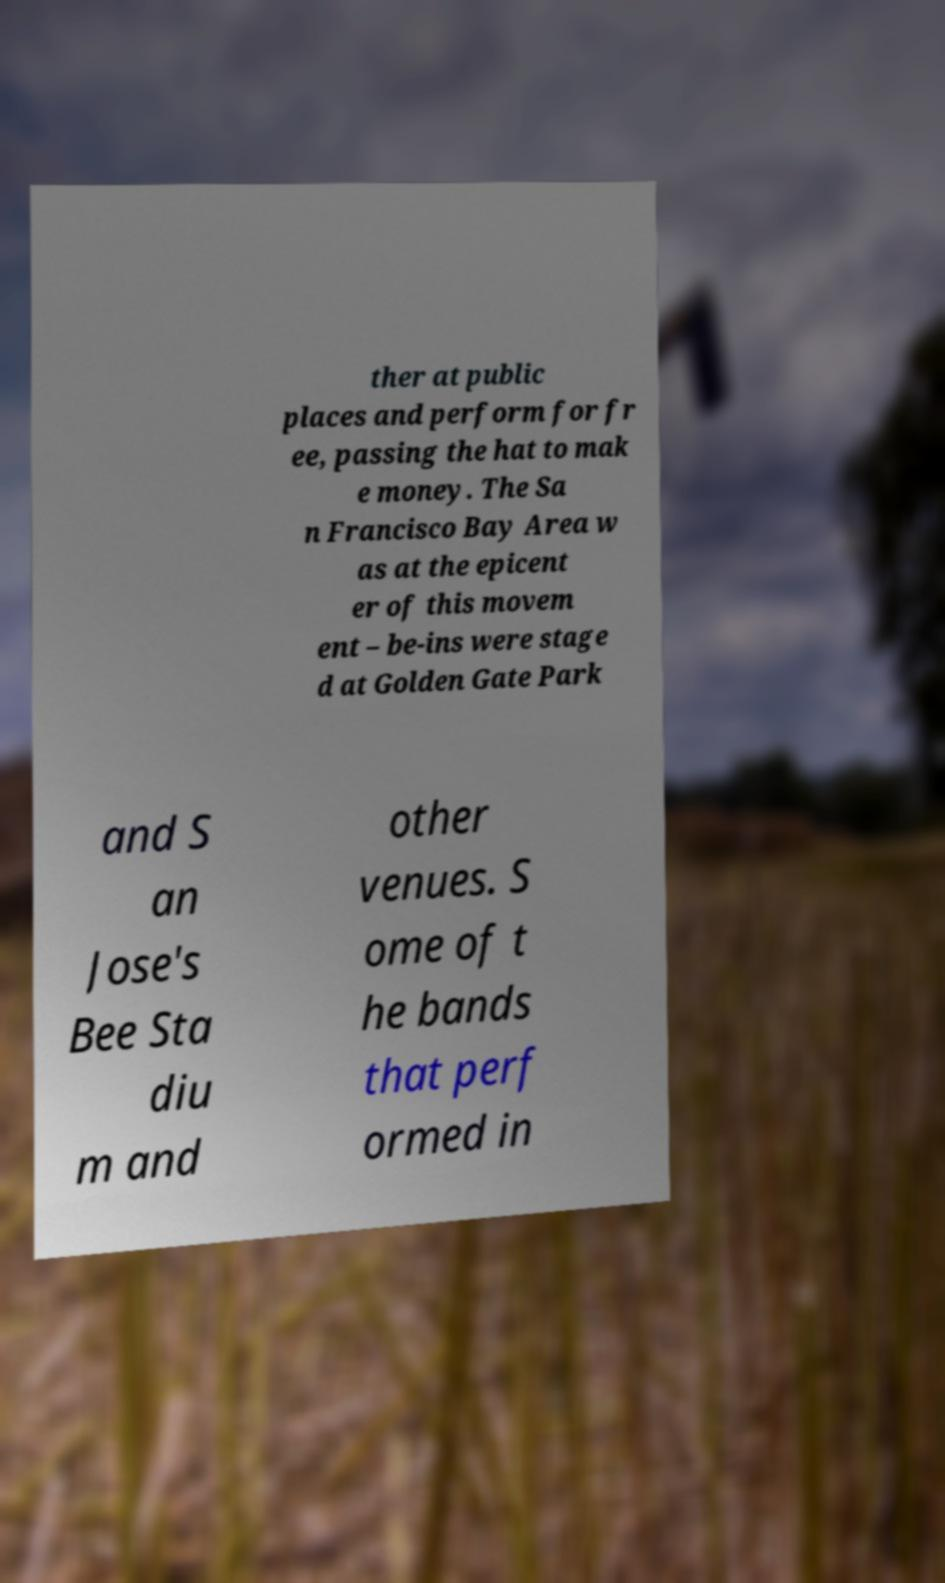There's text embedded in this image that I need extracted. Can you transcribe it verbatim? ther at public places and perform for fr ee, passing the hat to mak e money. The Sa n Francisco Bay Area w as at the epicent er of this movem ent – be-ins were stage d at Golden Gate Park and S an Jose's Bee Sta diu m and other venues. S ome of t he bands that perf ormed in 